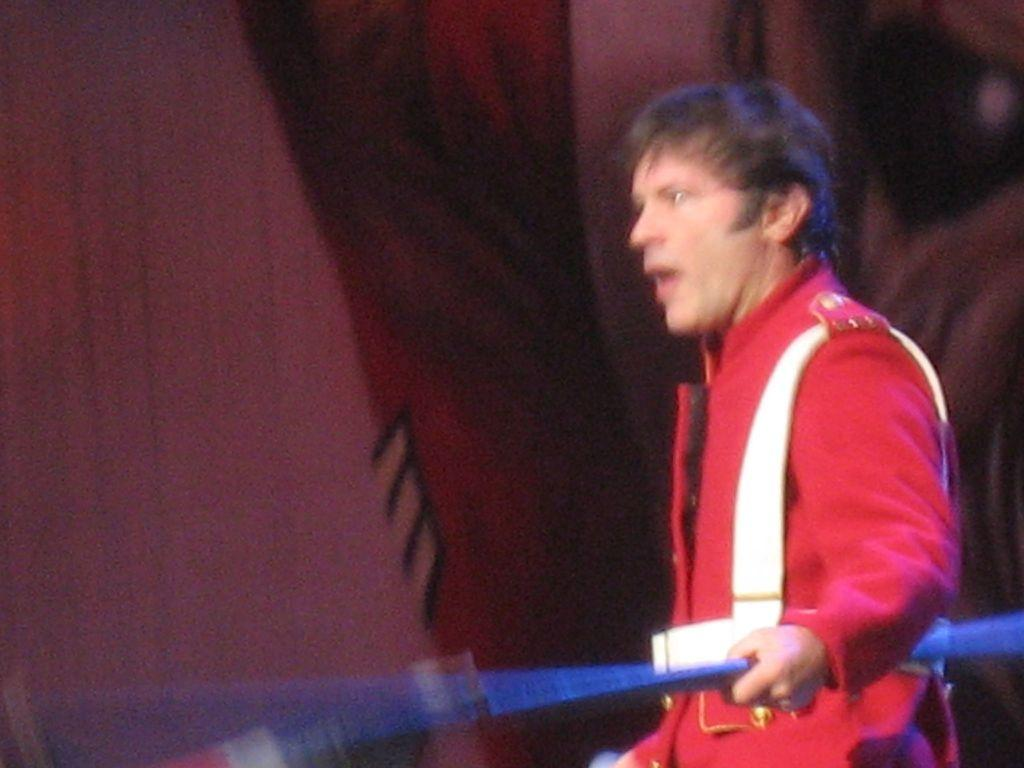What is the main subject of the image? There is a person standing in the image. What is the person doing in the image? The person is holding some objects. Can you describe the objects behind the person? There are objects visible behind the person. What type of sweater is the person wearing in the image? The provided facts do not mention a sweater, so we cannot determine if the person is wearing one or what type it might be. 